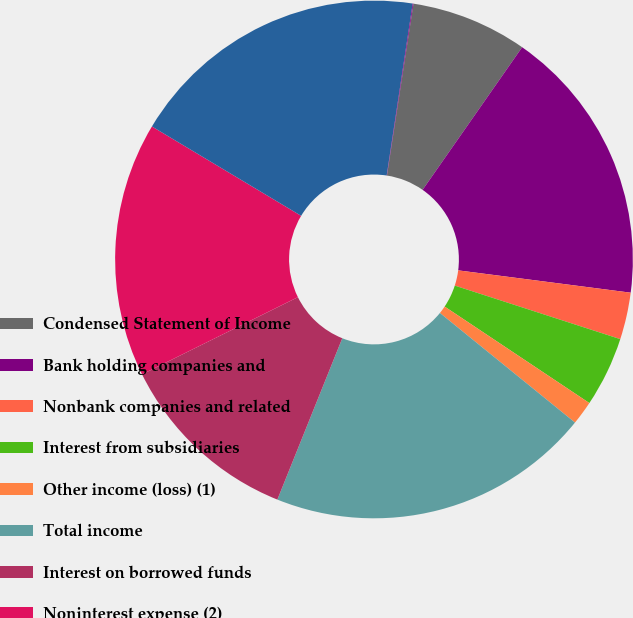Convert chart. <chart><loc_0><loc_0><loc_500><loc_500><pie_chart><fcel>Condensed Statement of Income<fcel>Bank holding companies and<fcel>Nonbank companies and related<fcel>Interest from subsidiaries<fcel>Other income (loss) (1)<fcel>Total income<fcel>Interest on borrowed funds<fcel>Noninterest expense (2)<fcel>Total expense<fcel>Income (loss) before income<nl><fcel>7.26%<fcel>17.35%<fcel>2.93%<fcel>4.38%<fcel>1.49%<fcel>20.24%<fcel>11.59%<fcel>15.91%<fcel>18.8%<fcel>0.05%<nl></chart> 